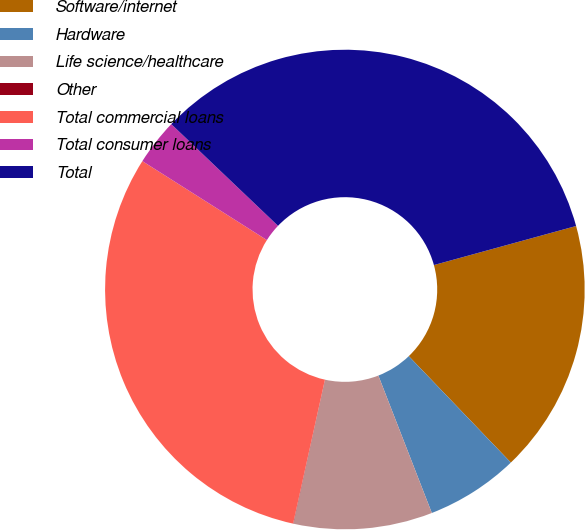<chart> <loc_0><loc_0><loc_500><loc_500><pie_chart><fcel>Software/internet<fcel>Hardware<fcel>Life science/healthcare<fcel>Other<fcel>Total commercial loans<fcel>Total consumer loans<fcel>Total<nl><fcel>17.1%<fcel>6.26%<fcel>9.35%<fcel>0.02%<fcel>30.53%<fcel>3.12%<fcel>33.62%<nl></chart> 